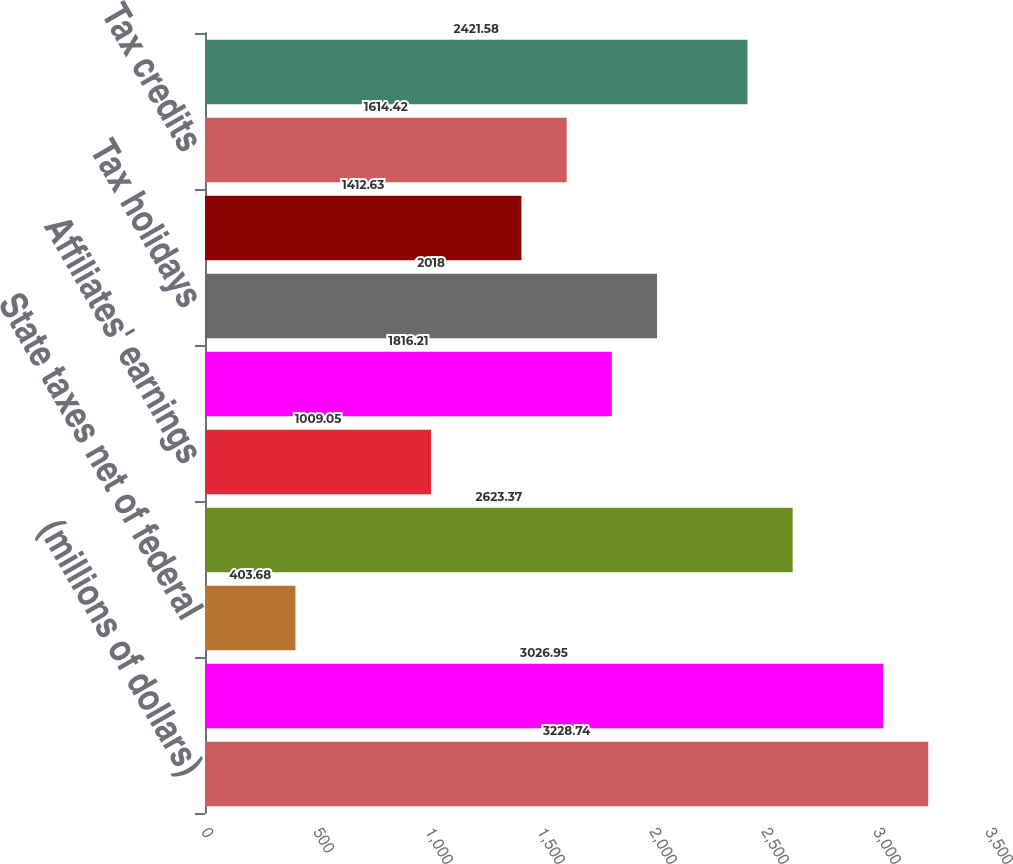Convert chart. <chart><loc_0><loc_0><loc_500><loc_500><bar_chart><fcel>(millions of dollars)<fcel>Income taxes at US statutory<fcel>State taxes net of federal<fcel>US tax on non-US earnings<fcel>Affiliates' earnings<fcel>Foreign rate differentials<fcel>Tax holidays<fcel>Net tax on remittance of<fcel>Tax credits<fcel>Reserve adjustments<nl><fcel>3228.74<fcel>3026.95<fcel>403.68<fcel>2623.37<fcel>1009.05<fcel>1816.21<fcel>2018<fcel>1412.63<fcel>1614.42<fcel>2421.58<nl></chart> 